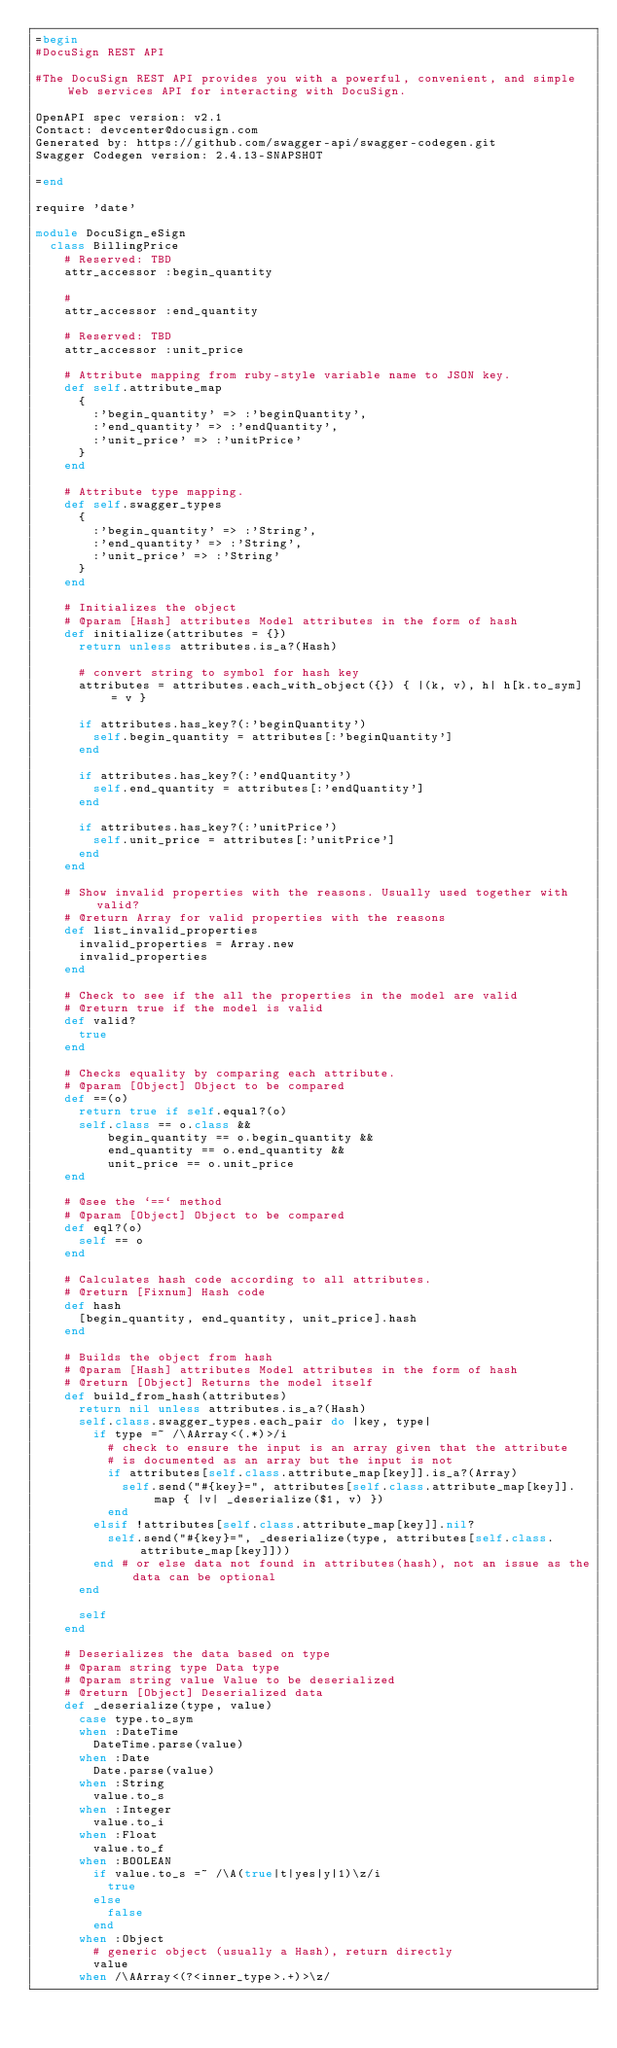Convert code to text. <code><loc_0><loc_0><loc_500><loc_500><_Ruby_>=begin
#DocuSign REST API

#The DocuSign REST API provides you with a powerful, convenient, and simple Web services API for interacting with DocuSign.

OpenAPI spec version: v2.1
Contact: devcenter@docusign.com
Generated by: https://github.com/swagger-api/swagger-codegen.git
Swagger Codegen version: 2.4.13-SNAPSHOT

=end

require 'date'

module DocuSign_eSign
  class BillingPrice
    # Reserved: TBD
    attr_accessor :begin_quantity

    # 
    attr_accessor :end_quantity

    # Reserved: TBD
    attr_accessor :unit_price

    # Attribute mapping from ruby-style variable name to JSON key.
    def self.attribute_map
      {
        :'begin_quantity' => :'beginQuantity',
        :'end_quantity' => :'endQuantity',
        :'unit_price' => :'unitPrice'
      }
    end

    # Attribute type mapping.
    def self.swagger_types
      {
        :'begin_quantity' => :'String',
        :'end_quantity' => :'String',
        :'unit_price' => :'String'
      }
    end

    # Initializes the object
    # @param [Hash] attributes Model attributes in the form of hash
    def initialize(attributes = {})
      return unless attributes.is_a?(Hash)

      # convert string to symbol for hash key
      attributes = attributes.each_with_object({}) { |(k, v), h| h[k.to_sym] = v }

      if attributes.has_key?(:'beginQuantity')
        self.begin_quantity = attributes[:'beginQuantity']
      end

      if attributes.has_key?(:'endQuantity')
        self.end_quantity = attributes[:'endQuantity']
      end

      if attributes.has_key?(:'unitPrice')
        self.unit_price = attributes[:'unitPrice']
      end
    end

    # Show invalid properties with the reasons. Usually used together with valid?
    # @return Array for valid properties with the reasons
    def list_invalid_properties
      invalid_properties = Array.new
      invalid_properties
    end

    # Check to see if the all the properties in the model are valid
    # @return true if the model is valid
    def valid?
      true
    end

    # Checks equality by comparing each attribute.
    # @param [Object] Object to be compared
    def ==(o)
      return true if self.equal?(o)
      self.class == o.class &&
          begin_quantity == o.begin_quantity &&
          end_quantity == o.end_quantity &&
          unit_price == o.unit_price
    end

    # @see the `==` method
    # @param [Object] Object to be compared
    def eql?(o)
      self == o
    end

    # Calculates hash code according to all attributes.
    # @return [Fixnum] Hash code
    def hash
      [begin_quantity, end_quantity, unit_price].hash
    end

    # Builds the object from hash
    # @param [Hash] attributes Model attributes in the form of hash
    # @return [Object] Returns the model itself
    def build_from_hash(attributes)
      return nil unless attributes.is_a?(Hash)
      self.class.swagger_types.each_pair do |key, type|
        if type =~ /\AArray<(.*)>/i
          # check to ensure the input is an array given that the attribute
          # is documented as an array but the input is not
          if attributes[self.class.attribute_map[key]].is_a?(Array)
            self.send("#{key}=", attributes[self.class.attribute_map[key]].map { |v| _deserialize($1, v) })
          end
        elsif !attributes[self.class.attribute_map[key]].nil?
          self.send("#{key}=", _deserialize(type, attributes[self.class.attribute_map[key]]))
        end # or else data not found in attributes(hash), not an issue as the data can be optional
      end

      self
    end

    # Deserializes the data based on type
    # @param string type Data type
    # @param string value Value to be deserialized
    # @return [Object] Deserialized data
    def _deserialize(type, value)
      case type.to_sym
      when :DateTime
        DateTime.parse(value)
      when :Date
        Date.parse(value)
      when :String
        value.to_s
      when :Integer
        value.to_i
      when :Float
        value.to_f
      when :BOOLEAN
        if value.to_s =~ /\A(true|t|yes|y|1)\z/i
          true
        else
          false
        end
      when :Object
        # generic object (usually a Hash), return directly
        value
      when /\AArray<(?<inner_type>.+)>\z/</code> 